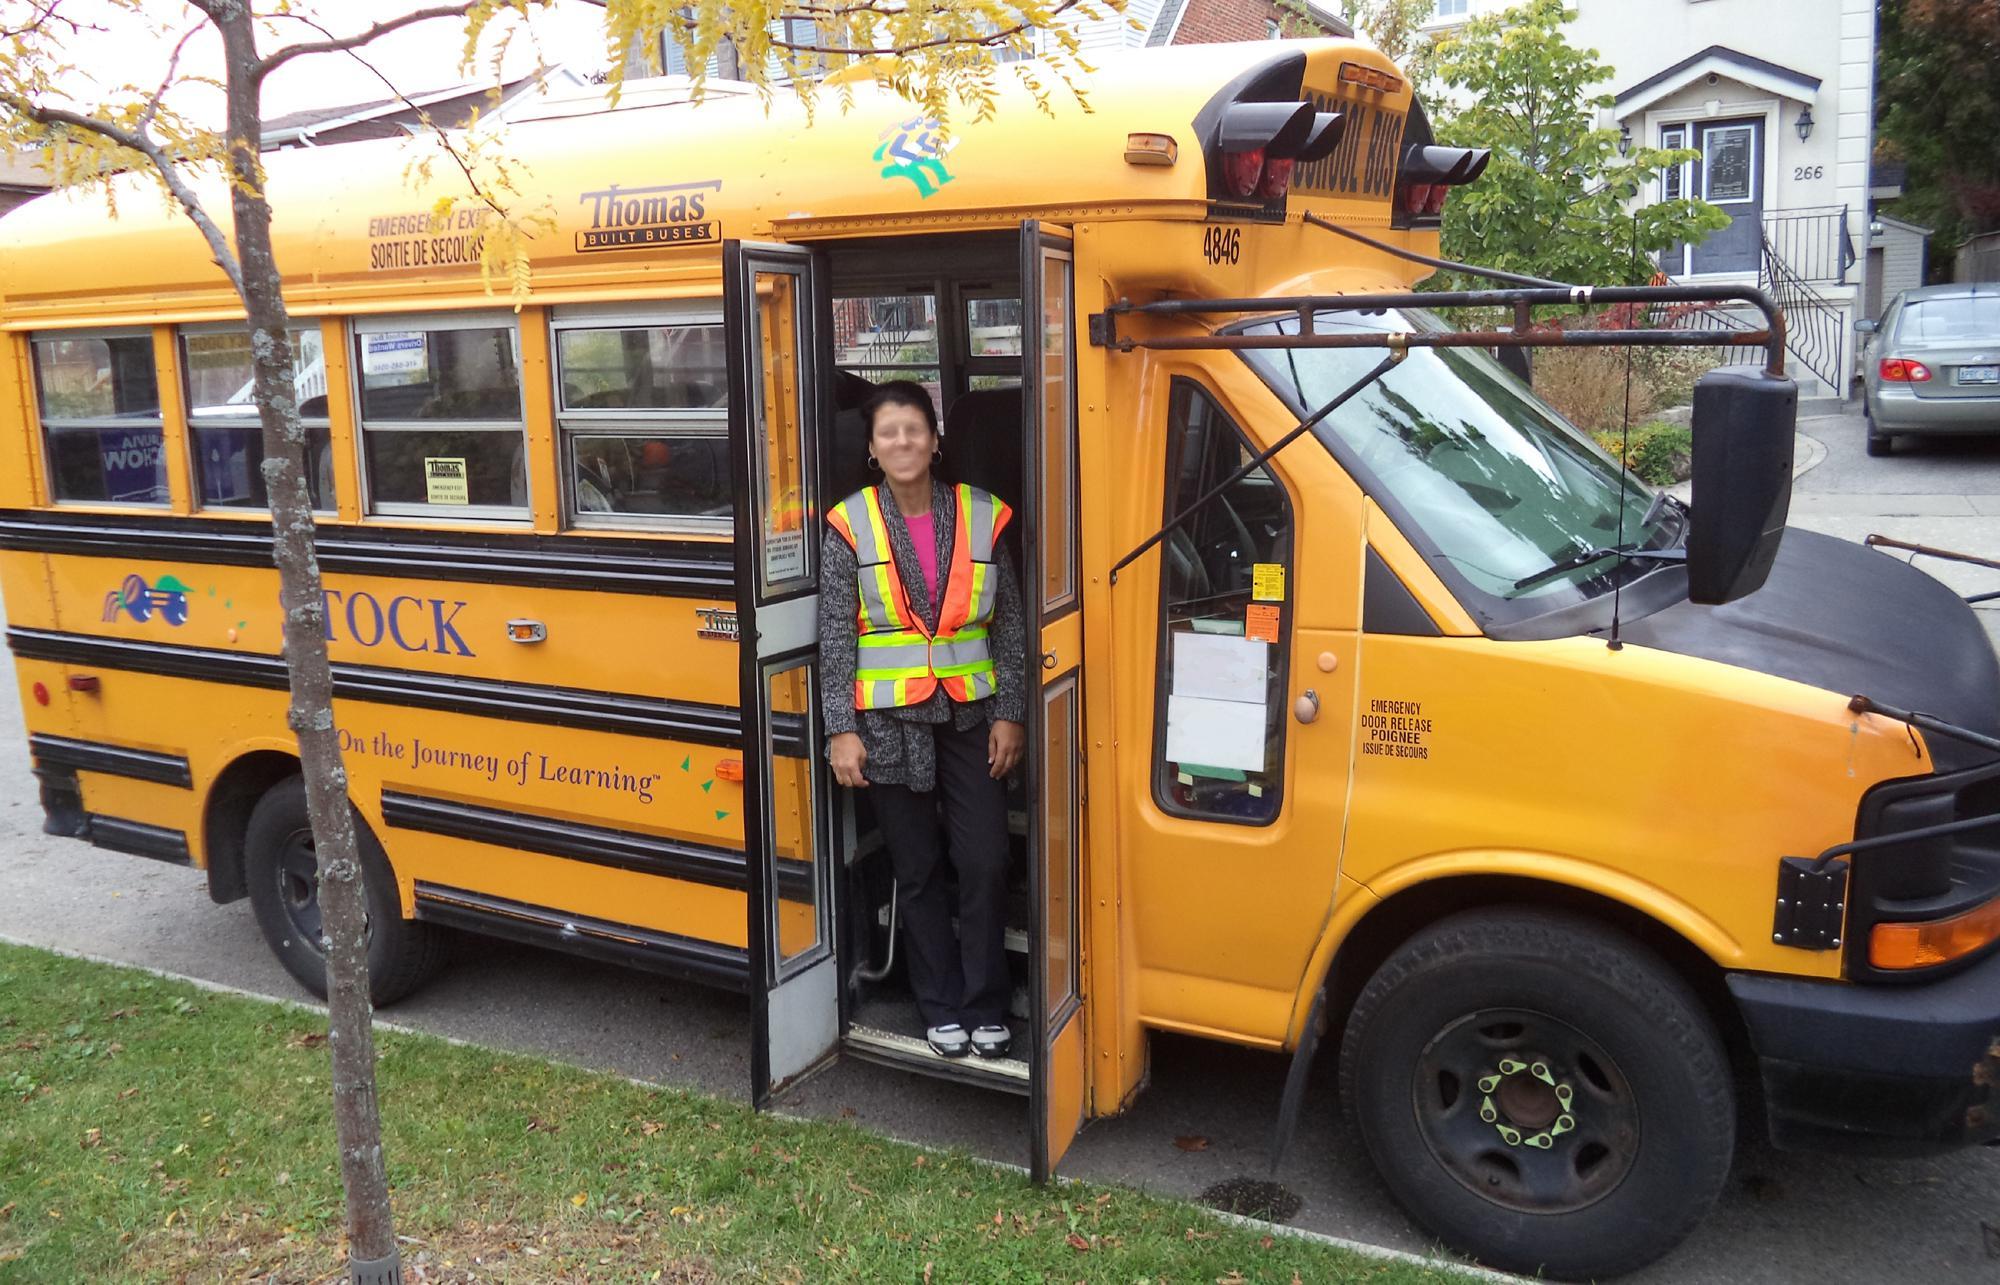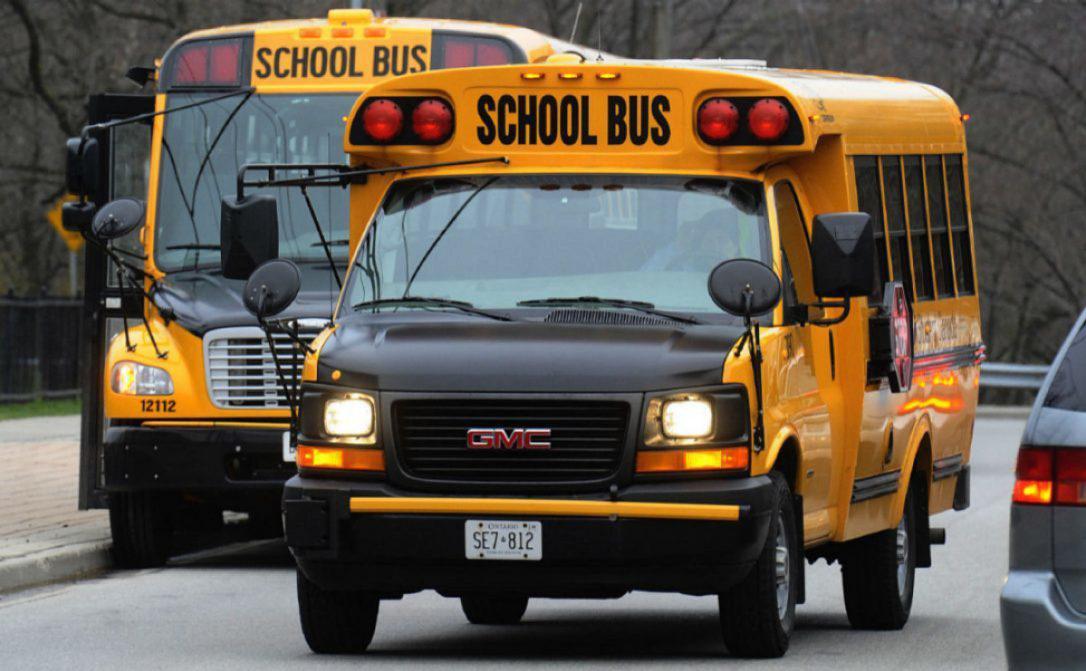The first image is the image on the left, the second image is the image on the right. Examine the images to the left and right. Is the description "the left and right image contains the same number of buses." accurate? Answer yes or no. No. The first image is the image on the left, the second image is the image on the right. Analyze the images presented: Is the assertion "In the left image, a person is in the open doorway of a bus that faces rightward, with at least one foot on the first step." valid? Answer yes or no. Yes. 